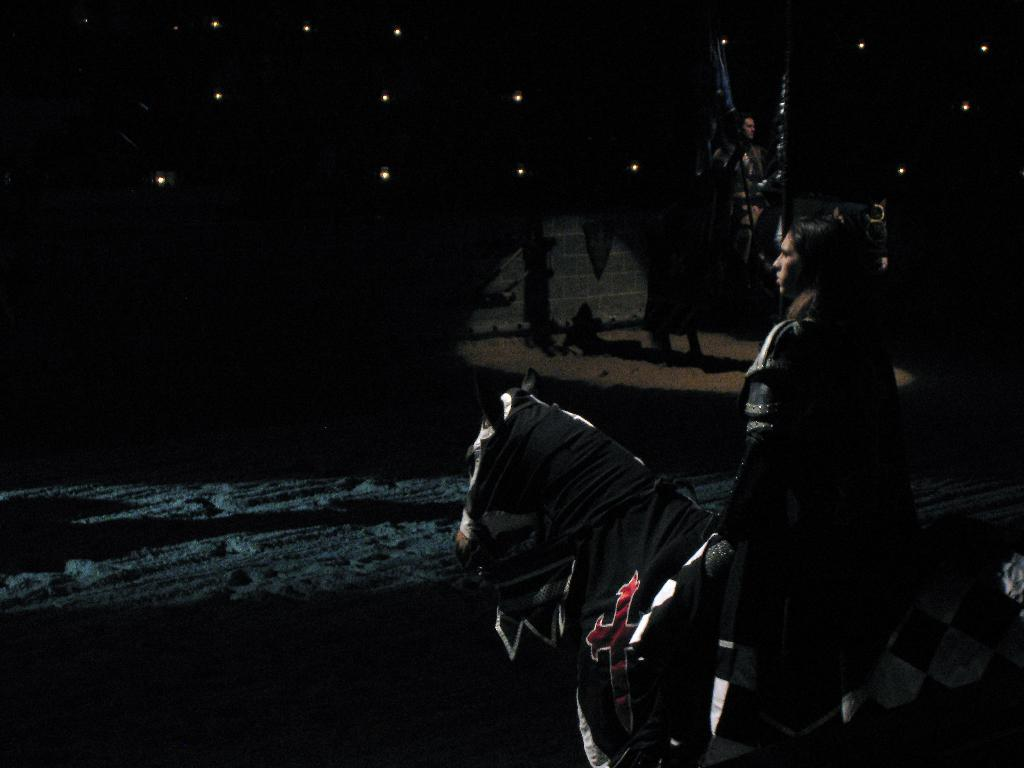What is the person in the image doing? The person is sitting on a horse. Can you describe the setting of the image? There is another person visible in the distance, and the ground appears to be sand. What else can be seen in the image? There are lights present. What type of robin can be seen interacting with the creature in the image? There is no robin or creature present in the image. 